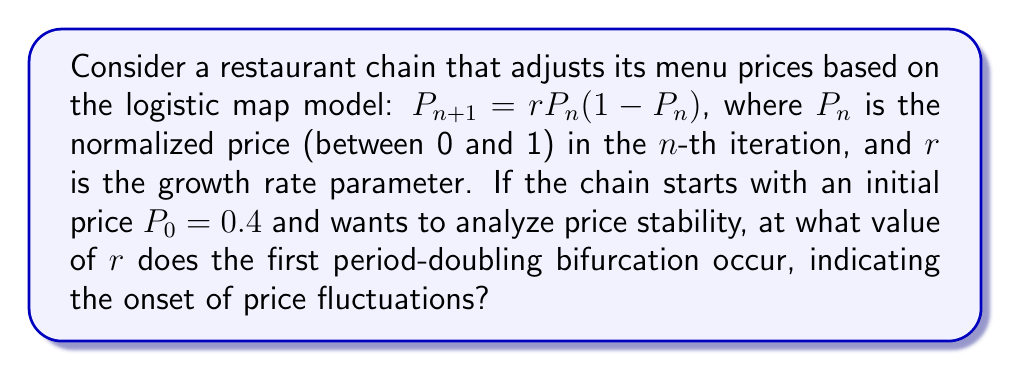Teach me how to tackle this problem. To find the first period-doubling bifurcation in the logistic map, we need to follow these steps:

1) The logistic map is given by: $P_{n+1} = rP_n(1-P_n)$

2) For a fixed point $P^*$, we have: $P^* = rP^*(1-P^*)$

3) Solving this equation:
   $P^* = rP^* - rP^{*2}$
   $rP^{*2} - rP^* + P^* = 0$
   $P^*(rP^* - r + 1) = 0$

4) The non-zero fixed point is: $P^* = 1 - \frac{1}{r}$ for $r > 1$

5) The stability of this fixed point changes when:
   $|\frac{d}{dP}(rP(1-P))|_{P=P^*} = |-2rP^* + r| = 1$

6) Substituting $P^* = 1 - \frac{1}{r}$:
   $|-2r(1 - \frac{1}{r}) + r| = 1$
   $|-2r + 2 + r| = 1$
   $|-r + 2| = 1$

7) Solving this equation:
   $-r + 2 = 1$ or $-r + 2 = -1$
   $r = 1$ or $r = 3$

8) The first period-doubling bifurcation occurs at $r = 3$, as $r = 1$ corresponds to the transcritical bifurcation.

Therefore, the first period-doubling bifurcation, indicating the onset of price fluctuations, occurs at $r = 3$.
Answer: $r = 3$ 